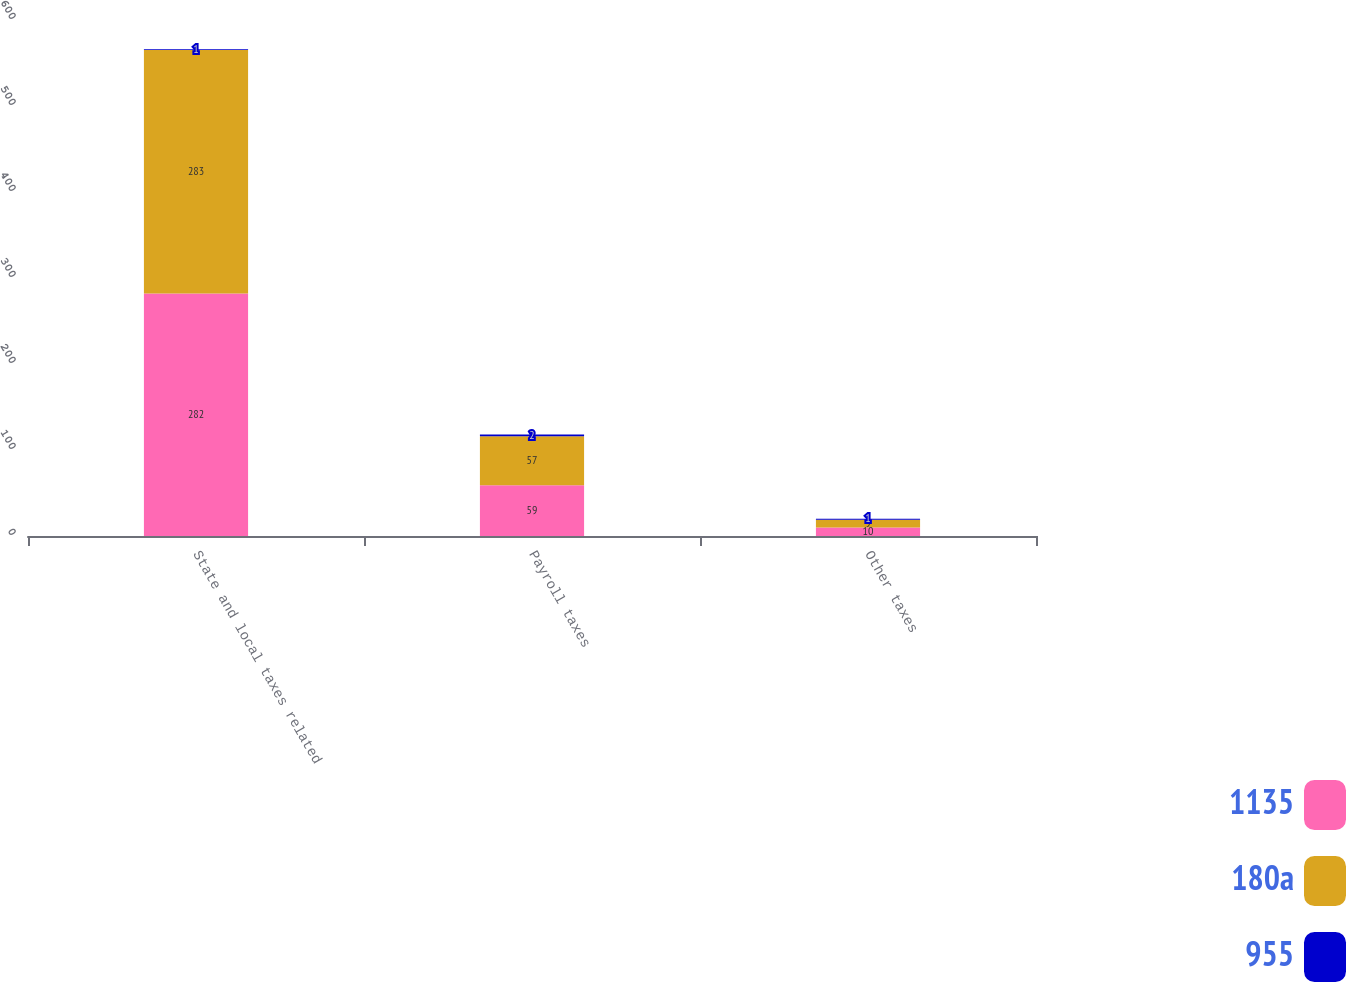Convert chart to OTSL. <chart><loc_0><loc_0><loc_500><loc_500><stacked_bar_chart><ecel><fcel>State and local taxes related<fcel>Payroll taxes<fcel>Other taxes<nl><fcel>1135<fcel>282<fcel>59<fcel>10<nl><fcel>180a<fcel>283<fcel>57<fcel>9<nl><fcel>955<fcel>1<fcel>2<fcel>1<nl></chart> 